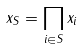Convert formula to latex. <formula><loc_0><loc_0><loc_500><loc_500>x _ { S } = \prod _ { i \in S } x _ { i }</formula> 